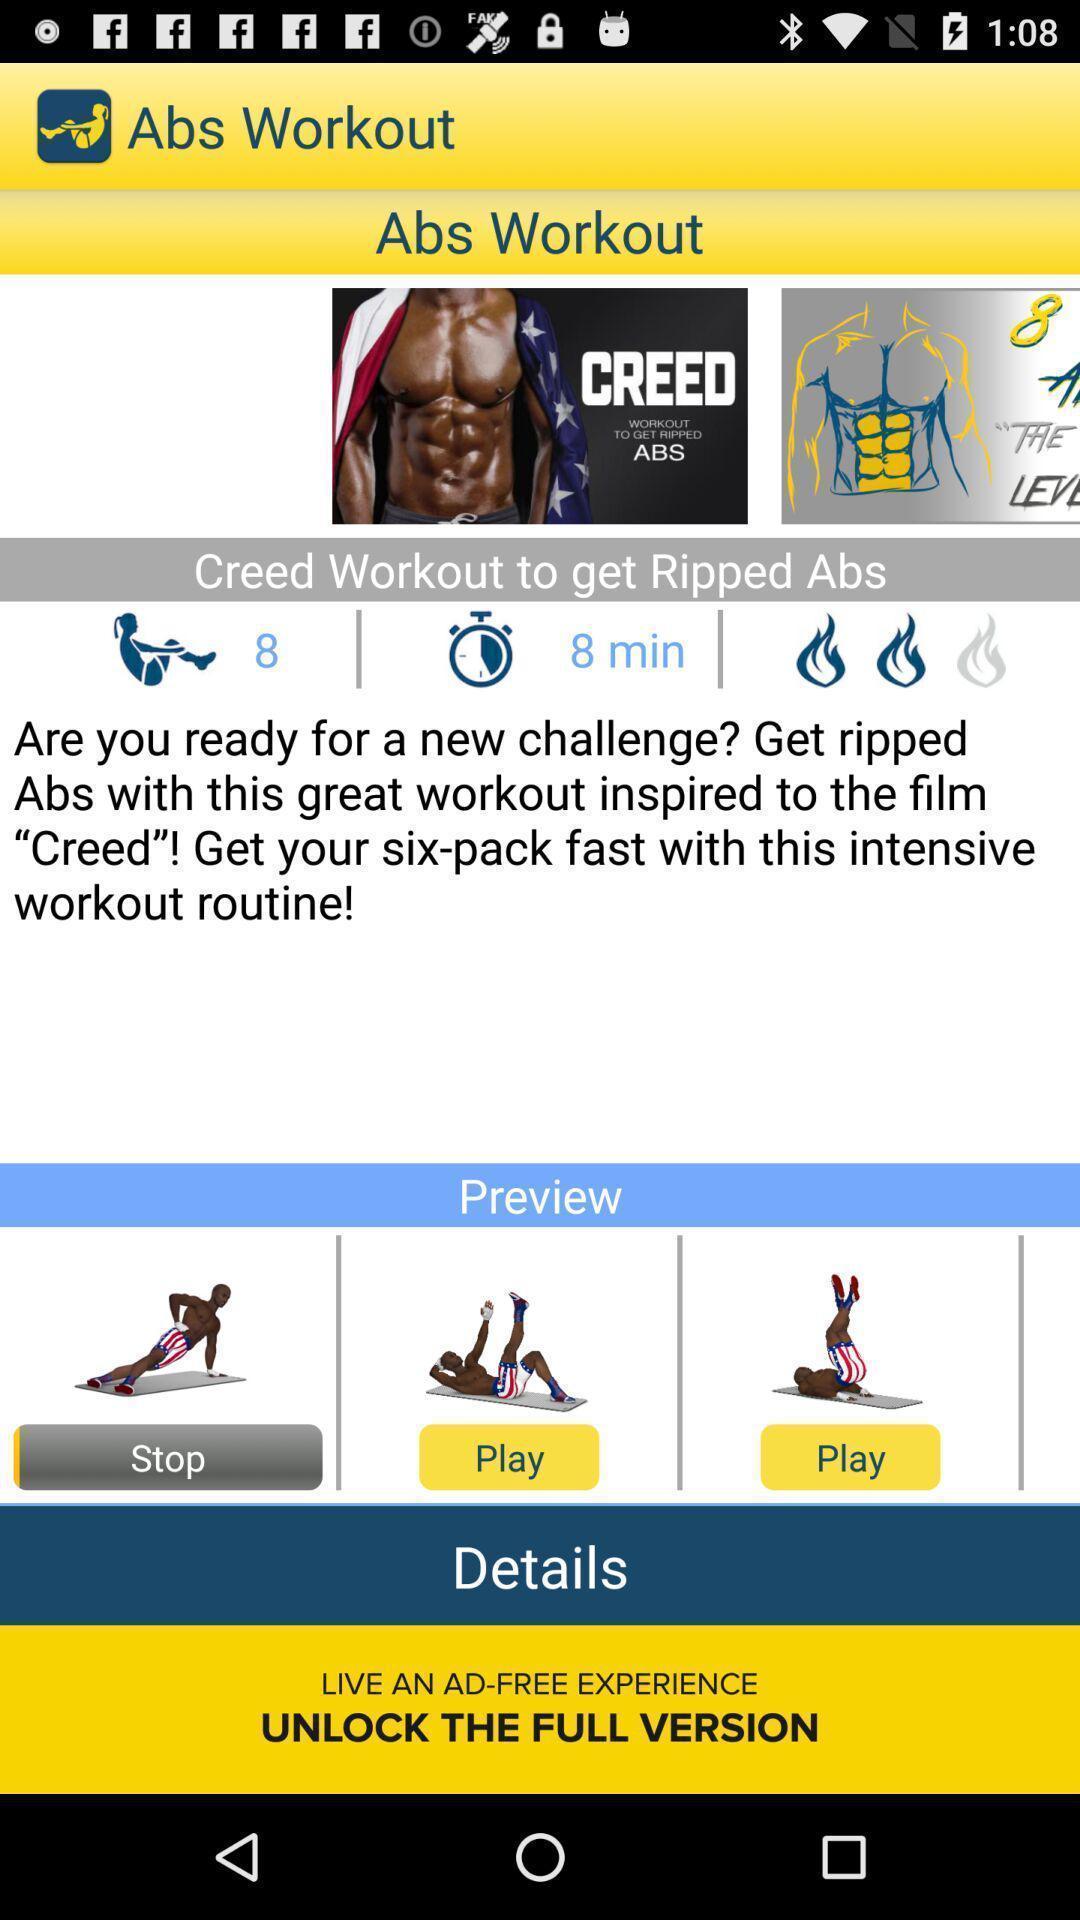Provide a detailed account of this screenshot. Page displaying information about a workout application. 